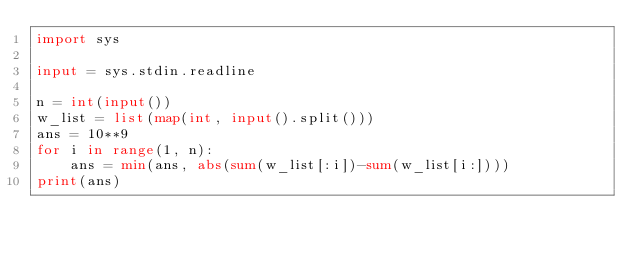<code> <loc_0><loc_0><loc_500><loc_500><_Python_>import sys

input = sys.stdin.readline

n = int(input())
w_list = list(map(int, input().split()))
ans = 10**9
for i in range(1, n):
    ans = min(ans, abs(sum(w_list[:i])-sum(w_list[i:])))
print(ans)
</code> 